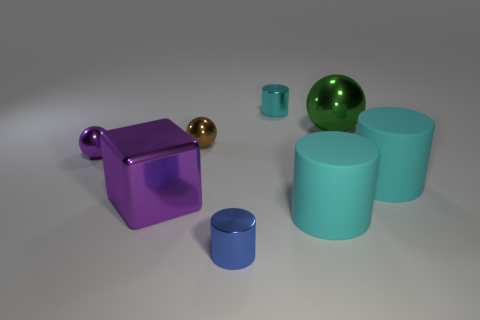Is the color of the big ball the same as the block?
Offer a very short reply. No. What number of small objects are either green metallic balls or gray rubber balls?
Offer a terse response. 0. Are there any other things that have the same color as the big sphere?
Your answer should be very brief. No. There is a tiny purple thing that is made of the same material as the tiny cyan object; what shape is it?
Ensure brevity in your answer.  Sphere. There is a cyan matte object to the right of the large sphere; what is its size?
Keep it short and to the point. Large. What is the shape of the small brown thing?
Your response must be concise. Sphere. Do the purple thing that is on the left side of the big purple object and the shiny ball that is on the right side of the tiny blue cylinder have the same size?
Your answer should be compact. No. How big is the metallic cylinder on the left side of the tiny cylinder behind the shiny cylinder that is in front of the small cyan shiny thing?
Your response must be concise. Small. What is the shape of the cyan rubber thing right of the large metallic object that is behind the large metallic thing to the left of the small cyan thing?
Give a very brief answer. Cylinder. There is a tiny thing on the right side of the blue shiny thing; what is its shape?
Provide a succinct answer. Cylinder. 